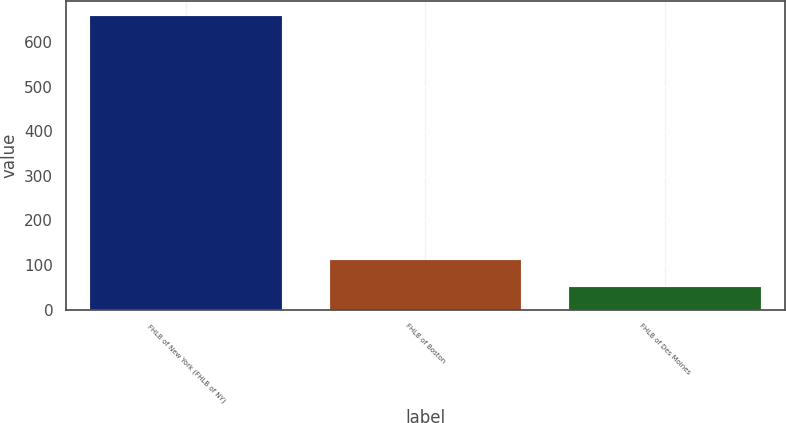<chart> <loc_0><loc_0><loc_500><loc_500><bar_chart><fcel>FHLB of New York (FHLB of NY)<fcel>FHLB of Boston<fcel>FHLB of Des Moines<nl><fcel>658<fcel>111.7<fcel>51<nl></chart> 